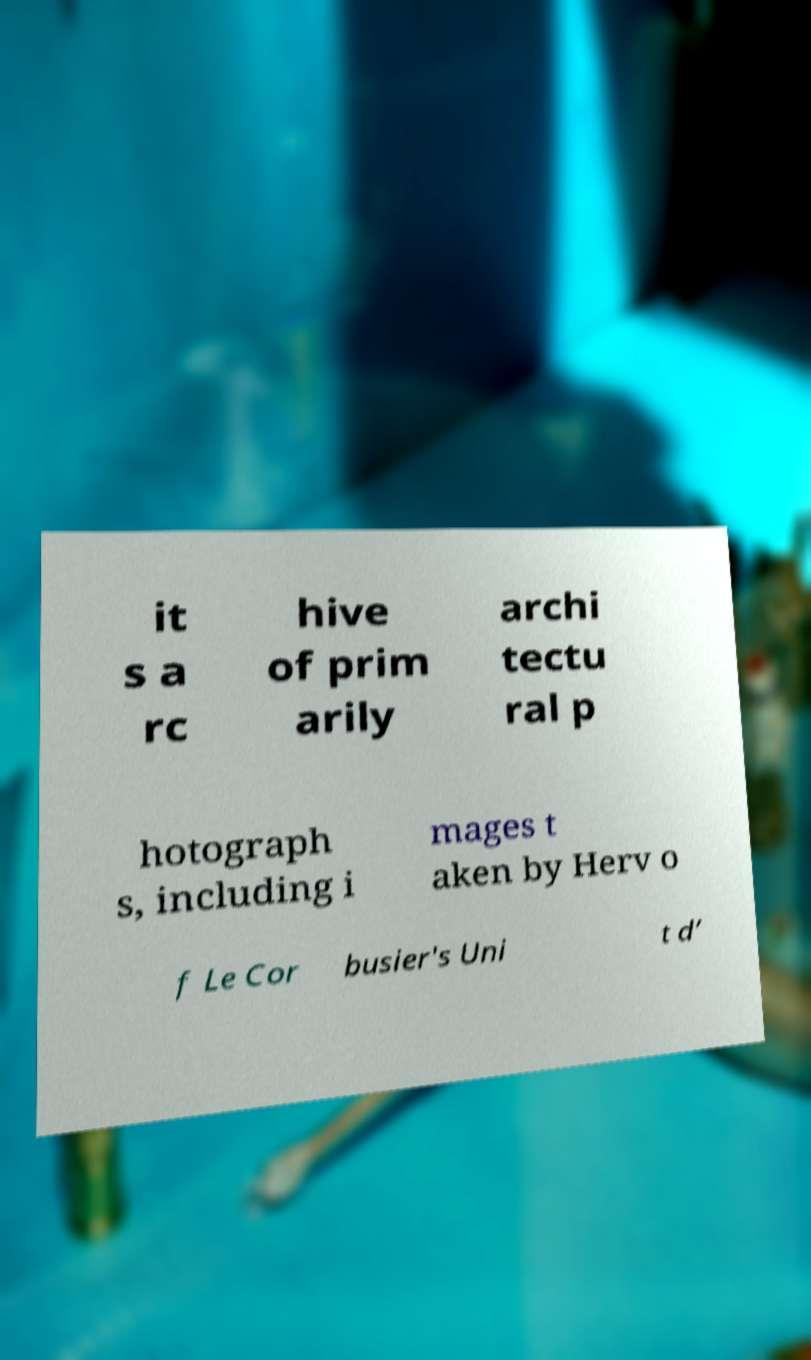There's text embedded in this image that I need extracted. Can you transcribe it verbatim? it s a rc hive of prim arily archi tectu ral p hotograph s, including i mages t aken by Herv o f Le Cor busier's Uni t d’ 